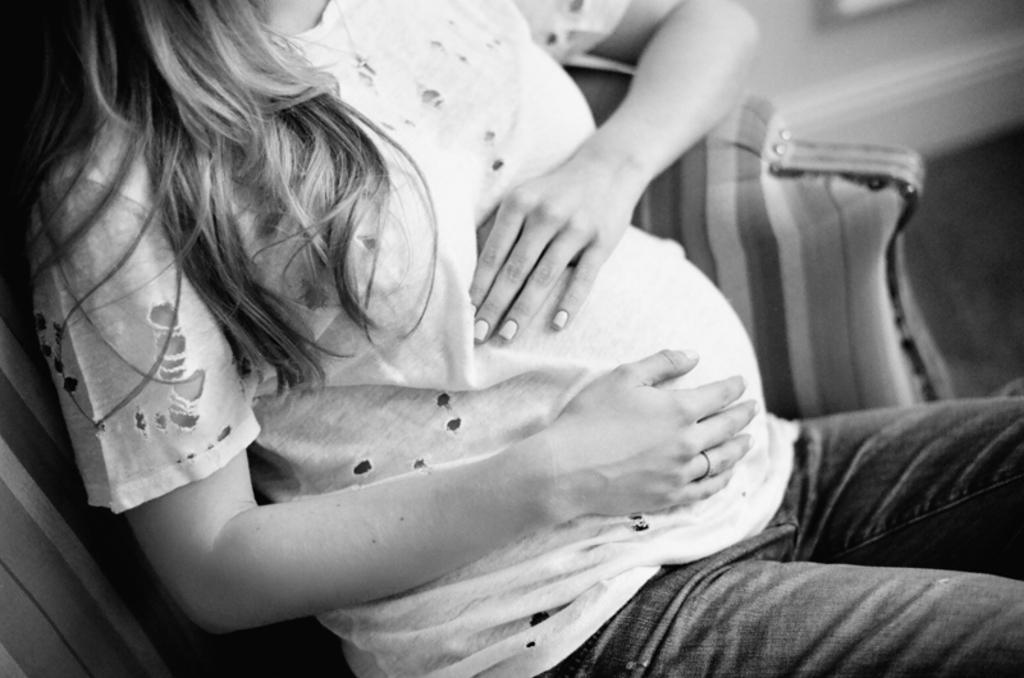How would you summarize this image in a sentence or two? In this image we can see a person sitting on the couch and blur background. 